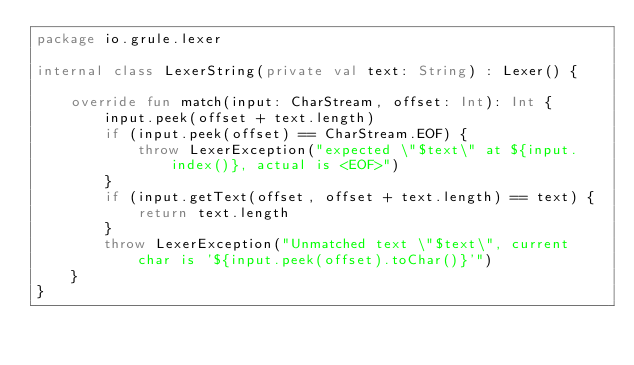<code> <loc_0><loc_0><loc_500><loc_500><_Kotlin_>package io.grule.lexer

internal class LexerString(private val text: String) : Lexer() {

    override fun match(input: CharStream, offset: Int): Int {
        input.peek(offset + text.length)
        if (input.peek(offset) == CharStream.EOF) {
            throw LexerException("expected \"$text\" at ${input.index()}, actual is <EOF>")
        }
        if (input.getText(offset, offset + text.length) == text) {
            return text.length
        }
        throw LexerException("Unmatched text \"$text\", current char is '${input.peek(offset).toChar()}'")
    }
}</code> 